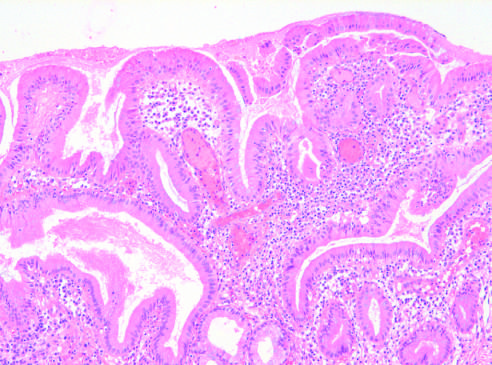what is the gallbladder mucosa infiltrated by?
Answer the question using a single word or phrase. Chronic inflammatory cells 